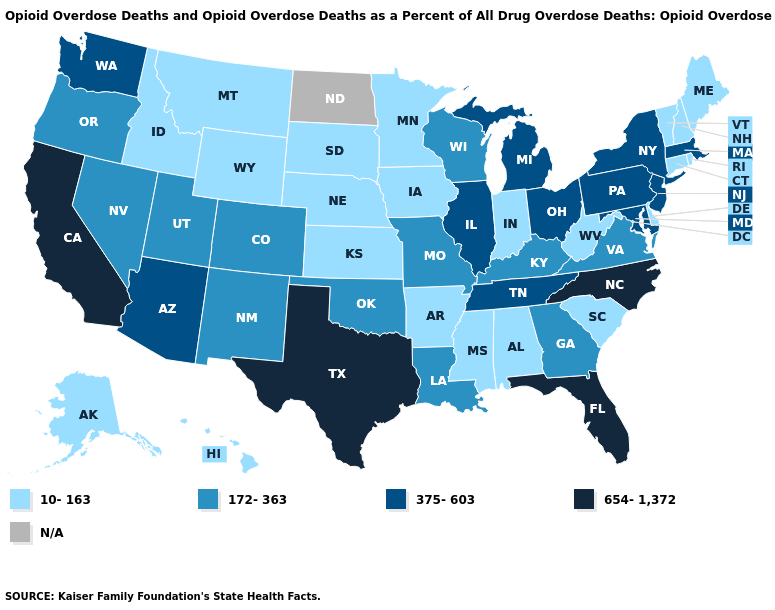What is the value of Delaware?
Answer briefly. 10-163. Does Delaware have the lowest value in the South?
Concise answer only. Yes. Is the legend a continuous bar?
Be succinct. No. Among the states that border Alabama , does Tennessee have the lowest value?
Keep it brief. No. What is the highest value in the USA?
Answer briefly. 654-1,372. What is the value of Alabama?
Write a very short answer. 10-163. Which states have the highest value in the USA?
Quick response, please. California, Florida, North Carolina, Texas. What is the value of Texas?
Concise answer only. 654-1,372. Name the states that have a value in the range 172-363?
Give a very brief answer. Colorado, Georgia, Kentucky, Louisiana, Missouri, Nevada, New Mexico, Oklahoma, Oregon, Utah, Virginia, Wisconsin. Name the states that have a value in the range 172-363?
Give a very brief answer. Colorado, Georgia, Kentucky, Louisiana, Missouri, Nevada, New Mexico, Oklahoma, Oregon, Utah, Virginia, Wisconsin. Among the states that border Arkansas , which have the highest value?
Write a very short answer. Texas. Does Utah have the lowest value in the USA?
Be succinct. No. Name the states that have a value in the range 654-1,372?
Short answer required. California, Florida, North Carolina, Texas. What is the value of Connecticut?
Quick response, please. 10-163. 